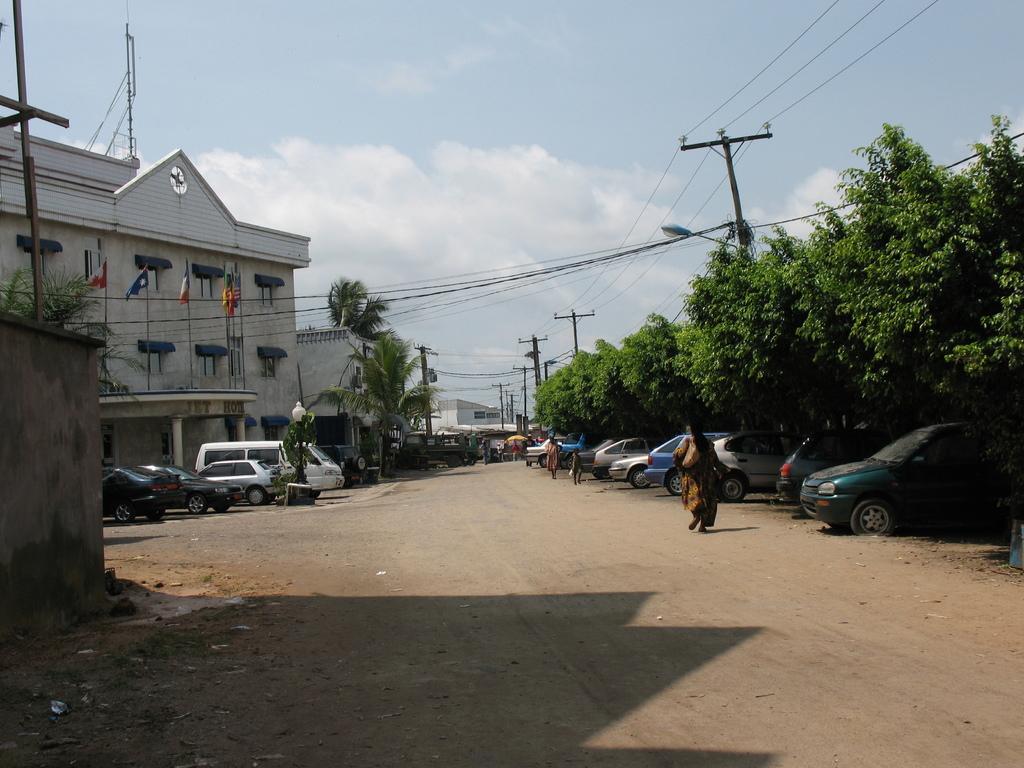Could you give a brief overview of what you see in this image? In the foreground of this image, on the right, there are trees, cars, poles and cables. In the middle, there are people walking on the path. On the left, there are few buildings, flags, trees, cables and vehicles. We can also see a wall on the left. At the top, there is the sky and the cloud. 